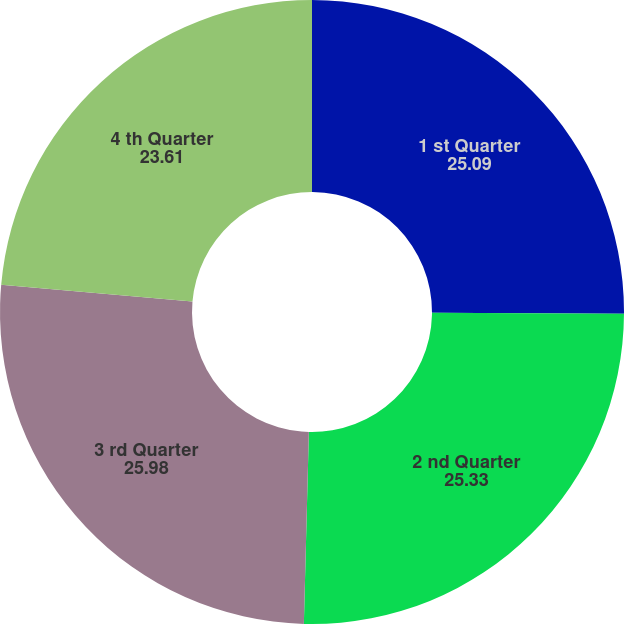Convert chart to OTSL. <chart><loc_0><loc_0><loc_500><loc_500><pie_chart><fcel>1 st Quarter<fcel>2 nd Quarter<fcel>3 rd Quarter<fcel>4 th Quarter<nl><fcel>25.09%<fcel>25.33%<fcel>25.98%<fcel>23.61%<nl></chart> 